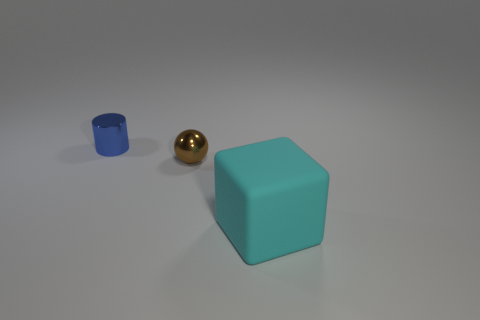There is a cylinder that is made of the same material as the tiny sphere; what color is it? The cylinder shares the same shimmering gold color as the tiny sphere, exhibiting a sleek and reflective surface that complements the sphere's appearance. 